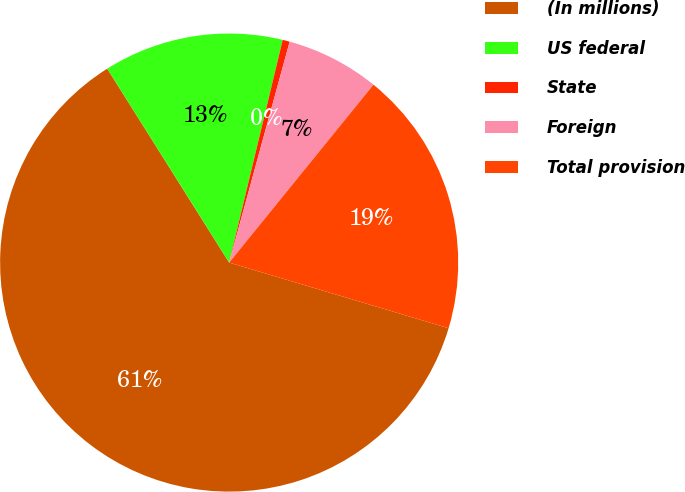Convert chart. <chart><loc_0><loc_0><loc_500><loc_500><pie_chart><fcel>(In millions)<fcel>US federal<fcel>State<fcel>Foreign<fcel>Total provision<nl><fcel>61.44%<fcel>12.69%<fcel>0.5%<fcel>6.59%<fcel>18.78%<nl></chart> 